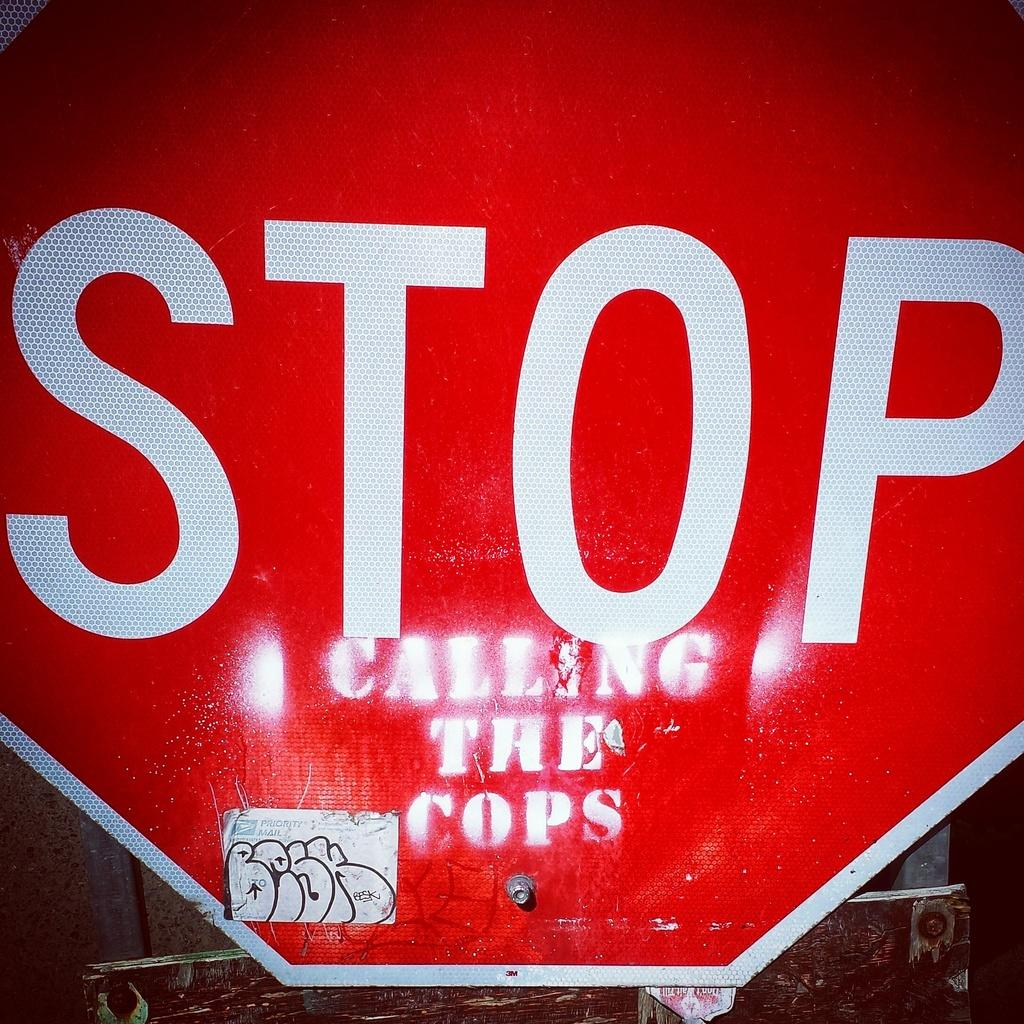<image>
Render a clear and concise summary of the photo. A stop sign with calling the cops painted on it. 